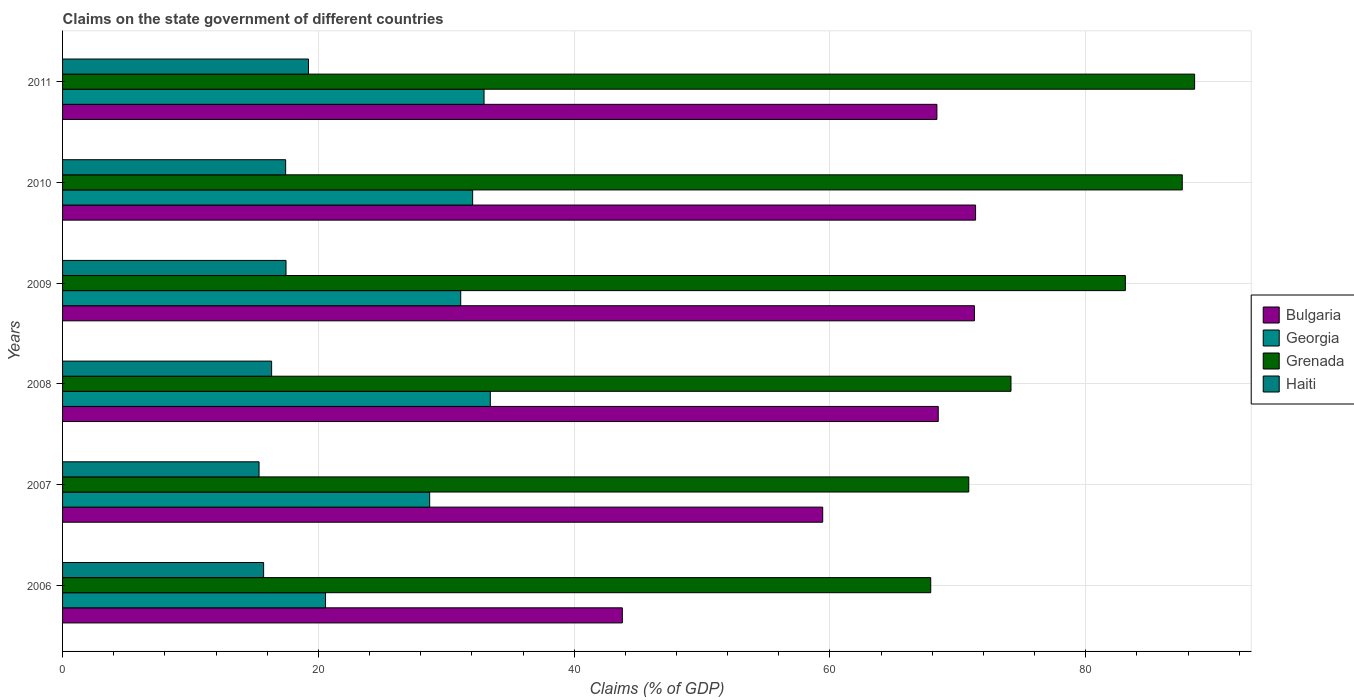How many groups of bars are there?
Your answer should be compact. 6. Are the number of bars per tick equal to the number of legend labels?
Your response must be concise. Yes. How many bars are there on the 4th tick from the top?
Give a very brief answer. 4. How many bars are there on the 6th tick from the bottom?
Ensure brevity in your answer.  4. What is the label of the 6th group of bars from the top?
Give a very brief answer. 2006. What is the percentage of GDP claimed on the state government in Grenada in 2008?
Provide a short and direct response. 74.15. Across all years, what is the maximum percentage of GDP claimed on the state government in Bulgaria?
Keep it short and to the point. 71.38. Across all years, what is the minimum percentage of GDP claimed on the state government in Bulgaria?
Your answer should be very brief. 43.77. In which year was the percentage of GDP claimed on the state government in Bulgaria maximum?
Make the answer very short. 2010. What is the total percentage of GDP claimed on the state government in Georgia in the graph?
Your answer should be compact. 178.85. What is the difference between the percentage of GDP claimed on the state government in Grenada in 2008 and that in 2010?
Offer a very short reply. -13.39. What is the difference between the percentage of GDP claimed on the state government in Haiti in 2010 and the percentage of GDP claimed on the state government in Bulgaria in 2011?
Offer a very short reply. -50.92. What is the average percentage of GDP claimed on the state government in Georgia per year?
Offer a very short reply. 29.81. In the year 2008, what is the difference between the percentage of GDP claimed on the state government in Georgia and percentage of GDP claimed on the state government in Haiti?
Your answer should be compact. 17.1. What is the ratio of the percentage of GDP claimed on the state government in Grenada in 2006 to that in 2010?
Offer a terse response. 0.78. Is the percentage of GDP claimed on the state government in Bulgaria in 2008 less than that in 2011?
Make the answer very short. No. What is the difference between the highest and the second highest percentage of GDP claimed on the state government in Bulgaria?
Keep it short and to the point. 0.09. What is the difference between the highest and the lowest percentage of GDP claimed on the state government in Grenada?
Keep it short and to the point. 20.63. What does the 2nd bar from the top in 2009 represents?
Your answer should be compact. Grenada. What does the 3rd bar from the bottom in 2011 represents?
Offer a very short reply. Grenada. How many bars are there?
Ensure brevity in your answer.  24. How many years are there in the graph?
Your response must be concise. 6. What is the difference between two consecutive major ticks on the X-axis?
Offer a terse response. 20. Does the graph contain any zero values?
Give a very brief answer. No. Does the graph contain grids?
Your answer should be very brief. Yes. Where does the legend appear in the graph?
Ensure brevity in your answer.  Center right. How many legend labels are there?
Your response must be concise. 4. What is the title of the graph?
Your response must be concise. Claims on the state government of different countries. What is the label or title of the X-axis?
Your answer should be compact. Claims (% of GDP). What is the label or title of the Y-axis?
Your answer should be compact. Years. What is the Claims (% of GDP) of Bulgaria in 2006?
Ensure brevity in your answer.  43.77. What is the Claims (% of GDP) in Georgia in 2006?
Keep it short and to the point. 20.56. What is the Claims (% of GDP) of Grenada in 2006?
Make the answer very short. 67.88. What is the Claims (% of GDP) in Haiti in 2006?
Offer a very short reply. 15.72. What is the Claims (% of GDP) in Bulgaria in 2007?
Give a very brief answer. 59.43. What is the Claims (% of GDP) of Georgia in 2007?
Make the answer very short. 28.7. What is the Claims (% of GDP) of Grenada in 2007?
Your answer should be compact. 70.85. What is the Claims (% of GDP) in Haiti in 2007?
Keep it short and to the point. 15.36. What is the Claims (% of GDP) in Bulgaria in 2008?
Your answer should be very brief. 68.46. What is the Claims (% of GDP) of Georgia in 2008?
Give a very brief answer. 33.44. What is the Claims (% of GDP) in Grenada in 2008?
Keep it short and to the point. 74.15. What is the Claims (% of GDP) in Haiti in 2008?
Your answer should be very brief. 16.34. What is the Claims (% of GDP) of Bulgaria in 2009?
Give a very brief answer. 71.29. What is the Claims (% of GDP) of Georgia in 2009?
Give a very brief answer. 31.13. What is the Claims (% of GDP) in Grenada in 2009?
Ensure brevity in your answer.  83.09. What is the Claims (% of GDP) in Haiti in 2009?
Give a very brief answer. 17.47. What is the Claims (% of GDP) of Bulgaria in 2010?
Offer a very short reply. 71.38. What is the Claims (% of GDP) of Georgia in 2010?
Offer a very short reply. 32.06. What is the Claims (% of GDP) of Grenada in 2010?
Make the answer very short. 87.54. What is the Claims (% of GDP) in Haiti in 2010?
Keep it short and to the point. 17.44. What is the Claims (% of GDP) of Bulgaria in 2011?
Your answer should be very brief. 68.36. What is the Claims (% of GDP) of Georgia in 2011?
Your response must be concise. 32.95. What is the Claims (% of GDP) in Grenada in 2011?
Your answer should be compact. 88.51. What is the Claims (% of GDP) in Haiti in 2011?
Make the answer very short. 19.23. Across all years, what is the maximum Claims (% of GDP) of Bulgaria?
Provide a succinct answer. 71.38. Across all years, what is the maximum Claims (% of GDP) in Georgia?
Make the answer very short. 33.44. Across all years, what is the maximum Claims (% of GDP) of Grenada?
Offer a very short reply. 88.51. Across all years, what is the maximum Claims (% of GDP) in Haiti?
Offer a terse response. 19.23. Across all years, what is the minimum Claims (% of GDP) of Bulgaria?
Your answer should be very brief. 43.77. Across all years, what is the minimum Claims (% of GDP) of Georgia?
Keep it short and to the point. 20.56. Across all years, what is the minimum Claims (% of GDP) of Grenada?
Your answer should be compact. 67.88. Across all years, what is the minimum Claims (% of GDP) in Haiti?
Offer a very short reply. 15.36. What is the total Claims (% of GDP) of Bulgaria in the graph?
Your answer should be very brief. 382.69. What is the total Claims (% of GDP) of Georgia in the graph?
Keep it short and to the point. 178.85. What is the total Claims (% of GDP) in Grenada in the graph?
Ensure brevity in your answer.  472.02. What is the total Claims (% of GDP) in Haiti in the graph?
Make the answer very short. 101.56. What is the difference between the Claims (% of GDP) in Bulgaria in 2006 and that in 2007?
Ensure brevity in your answer.  -15.66. What is the difference between the Claims (% of GDP) of Georgia in 2006 and that in 2007?
Your response must be concise. -8.14. What is the difference between the Claims (% of GDP) in Grenada in 2006 and that in 2007?
Ensure brevity in your answer.  -2.97. What is the difference between the Claims (% of GDP) of Haiti in 2006 and that in 2007?
Provide a short and direct response. 0.36. What is the difference between the Claims (% of GDP) of Bulgaria in 2006 and that in 2008?
Ensure brevity in your answer.  -24.7. What is the difference between the Claims (% of GDP) in Georgia in 2006 and that in 2008?
Your response must be concise. -12.88. What is the difference between the Claims (% of GDP) in Grenada in 2006 and that in 2008?
Ensure brevity in your answer.  -6.27. What is the difference between the Claims (% of GDP) in Haiti in 2006 and that in 2008?
Offer a very short reply. -0.62. What is the difference between the Claims (% of GDP) in Bulgaria in 2006 and that in 2009?
Provide a short and direct response. -27.53. What is the difference between the Claims (% of GDP) of Georgia in 2006 and that in 2009?
Provide a succinct answer. -10.57. What is the difference between the Claims (% of GDP) of Grenada in 2006 and that in 2009?
Give a very brief answer. -15.22. What is the difference between the Claims (% of GDP) of Haiti in 2006 and that in 2009?
Offer a very short reply. -1.75. What is the difference between the Claims (% of GDP) in Bulgaria in 2006 and that in 2010?
Your response must be concise. -27.62. What is the difference between the Claims (% of GDP) of Georgia in 2006 and that in 2010?
Your response must be concise. -11.5. What is the difference between the Claims (% of GDP) in Grenada in 2006 and that in 2010?
Make the answer very short. -19.66. What is the difference between the Claims (% of GDP) in Haiti in 2006 and that in 2010?
Provide a short and direct response. -1.72. What is the difference between the Claims (% of GDP) of Bulgaria in 2006 and that in 2011?
Make the answer very short. -24.59. What is the difference between the Claims (% of GDP) of Georgia in 2006 and that in 2011?
Make the answer very short. -12.39. What is the difference between the Claims (% of GDP) in Grenada in 2006 and that in 2011?
Provide a short and direct response. -20.63. What is the difference between the Claims (% of GDP) in Haiti in 2006 and that in 2011?
Make the answer very short. -3.51. What is the difference between the Claims (% of GDP) in Bulgaria in 2007 and that in 2008?
Provide a short and direct response. -9.03. What is the difference between the Claims (% of GDP) of Georgia in 2007 and that in 2008?
Your answer should be compact. -4.74. What is the difference between the Claims (% of GDP) in Grenada in 2007 and that in 2008?
Offer a very short reply. -3.3. What is the difference between the Claims (% of GDP) of Haiti in 2007 and that in 2008?
Give a very brief answer. -0.98. What is the difference between the Claims (% of GDP) of Bulgaria in 2007 and that in 2009?
Provide a succinct answer. -11.86. What is the difference between the Claims (% of GDP) of Georgia in 2007 and that in 2009?
Offer a terse response. -2.43. What is the difference between the Claims (% of GDP) of Grenada in 2007 and that in 2009?
Your answer should be very brief. -12.24. What is the difference between the Claims (% of GDP) of Haiti in 2007 and that in 2009?
Give a very brief answer. -2.11. What is the difference between the Claims (% of GDP) in Bulgaria in 2007 and that in 2010?
Your response must be concise. -11.95. What is the difference between the Claims (% of GDP) in Georgia in 2007 and that in 2010?
Your answer should be compact. -3.36. What is the difference between the Claims (% of GDP) in Grenada in 2007 and that in 2010?
Provide a succinct answer. -16.69. What is the difference between the Claims (% of GDP) in Haiti in 2007 and that in 2010?
Give a very brief answer. -2.08. What is the difference between the Claims (% of GDP) of Bulgaria in 2007 and that in 2011?
Your answer should be compact. -8.93. What is the difference between the Claims (% of GDP) in Georgia in 2007 and that in 2011?
Your answer should be compact. -4.25. What is the difference between the Claims (% of GDP) in Grenada in 2007 and that in 2011?
Keep it short and to the point. -17.66. What is the difference between the Claims (% of GDP) in Haiti in 2007 and that in 2011?
Give a very brief answer. -3.86. What is the difference between the Claims (% of GDP) in Bulgaria in 2008 and that in 2009?
Provide a succinct answer. -2.83. What is the difference between the Claims (% of GDP) in Georgia in 2008 and that in 2009?
Your answer should be very brief. 2.31. What is the difference between the Claims (% of GDP) in Grenada in 2008 and that in 2009?
Your answer should be compact. -8.94. What is the difference between the Claims (% of GDP) in Haiti in 2008 and that in 2009?
Your answer should be compact. -1.13. What is the difference between the Claims (% of GDP) in Bulgaria in 2008 and that in 2010?
Keep it short and to the point. -2.92. What is the difference between the Claims (% of GDP) in Georgia in 2008 and that in 2010?
Ensure brevity in your answer.  1.38. What is the difference between the Claims (% of GDP) in Grenada in 2008 and that in 2010?
Give a very brief answer. -13.39. What is the difference between the Claims (% of GDP) in Haiti in 2008 and that in 2010?
Make the answer very short. -1.1. What is the difference between the Claims (% of GDP) in Bulgaria in 2008 and that in 2011?
Your answer should be compact. 0.1. What is the difference between the Claims (% of GDP) of Georgia in 2008 and that in 2011?
Provide a succinct answer. 0.49. What is the difference between the Claims (% of GDP) in Grenada in 2008 and that in 2011?
Ensure brevity in your answer.  -14.36. What is the difference between the Claims (% of GDP) in Haiti in 2008 and that in 2011?
Keep it short and to the point. -2.88. What is the difference between the Claims (% of GDP) of Bulgaria in 2009 and that in 2010?
Your response must be concise. -0.09. What is the difference between the Claims (% of GDP) of Georgia in 2009 and that in 2010?
Give a very brief answer. -0.93. What is the difference between the Claims (% of GDP) of Grenada in 2009 and that in 2010?
Offer a terse response. -4.45. What is the difference between the Claims (% of GDP) of Haiti in 2009 and that in 2010?
Keep it short and to the point. 0.03. What is the difference between the Claims (% of GDP) of Bulgaria in 2009 and that in 2011?
Give a very brief answer. 2.93. What is the difference between the Claims (% of GDP) of Georgia in 2009 and that in 2011?
Make the answer very short. -1.82. What is the difference between the Claims (% of GDP) of Grenada in 2009 and that in 2011?
Offer a very short reply. -5.41. What is the difference between the Claims (% of GDP) of Haiti in 2009 and that in 2011?
Provide a succinct answer. -1.76. What is the difference between the Claims (% of GDP) in Bulgaria in 2010 and that in 2011?
Make the answer very short. 3.02. What is the difference between the Claims (% of GDP) of Georgia in 2010 and that in 2011?
Offer a very short reply. -0.89. What is the difference between the Claims (% of GDP) of Grenada in 2010 and that in 2011?
Your answer should be compact. -0.97. What is the difference between the Claims (% of GDP) of Haiti in 2010 and that in 2011?
Your response must be concise. -1.78. What is the difference between the Claims (% of GDP) in Bulgaria in 2006 and the Claims (% of GDP) in Georgia in 2007?
Your answer should be compact. 15.06. What is the difference between the Claims (% of GDP) in Bulgaria in 2006 and the Claims (% of GDP) in Grenada in 2007?
Give a very brief answer. -27.09. What is the difference between the Claims (% of GDP) in Bulgaria in 2006 and the Claims (% of GDP) in Haiti in 2007?
Make the answer very short. 28.4. What is the difference between the Claims (% of GDP) in Georgia in 2006 and the Claims (% of GDP) in Grenada in 2007?
Offer a terse response. -50.29. What is the difference between the Claims (% of GDP) of Georgia in 2006 and the Claims (% of GDP) of Haiti in 2007?
Make the answer very short. 5.2. What is the difference between the Claims (% of GDP) of Grenada in 2006 and the Claims (% of GDP) of Haiti in 2007?
Offer a terse response. 52.51. What is the difference between the Claims (% of GDP) of Bulgaria in 2006 and the Claims (% of GDP) of Georgia in 2008?
Provide a succinct answer. 10.32. What is the difference between the Claims (% of GDP) in Bulgaria in 2006 and the Claims (% of GDP) in Grenada in 2008?
Your answer should be very brief. -30.39. What is the difference between the Claims (% of GDP) in Bulgaria in 2006 and the Claims (% of GDP) in Haiti in 2008?
Provide a succinct answer. 27.42. What is the difference between the Claims (% of GDP) in Georgia in 2006 and the Claims (% of GDP) in Grenada in 2008?
Your response must be concise. -53.59. What is the difference between the Claims (% of GDP) of Georgia in 2006 and the Claims (% of GDP) of Haiti in 2008?
Provide a short and direct response. 4.22. What is the difference between the Claims (% of GDP) of Grenada in 2006 and the Claims (% of GDP) of Haiti in 2008?
Offer a very short reply. 51.53. What is the difference between the Claims (% of GDP) of Bulgaria in 2006 and the Claims (% of GDP) of Georgia in 2009?
Make the answer very short. 12.64. What is the difference between the Claims (% of GDP) of Bulgaria in 2006 and the Claims (% of GDP) of Grenada in 2009?
Provide a succinct answer. -39.33. What is the difference between the Claims (% of GDP) in Bulgaria in 2006 and the Claims (% of GDP) in Haiti in 2009?
Offer a very short reply. 26.3. What is the difference between the Claims (% of GDP) of Georgia in 2006 and the Claims (% of GDP) of Grenada in 2009?
Your answer should be very brief. -62.53. What is the difference between the Claims (% of GDP) in Georgia in 2006 and the Claims (% of GDP) in Haiti in 2009?
Provide a short and direct response. 3.09. What is the difference between the Claims (% of GDP) of Grenada in 2006 and the Claims (% of GDP) of Haiti in 2009?
Offer a terse response. 50.41. What is the difference between the Claims (% of GDP) in Bulgaria in 2006 and the Claims (% of GDP) in Georgia in 2010?
Keep it short and to the point. 11.7. What is the difference between the Claims (% of GDP) of Bulgaria in 2006 and the Claims (% of GDP) of Grenada in 2010?
Provide a short and direct response. -43.78. What is the difference between the Claims (% of GDP) of Bulgaria in 2006 and the Claims (% of GDP) of Haiti in 2010?
Offer a terse response. 26.32. What is the difference between the Claims (% of GDP) in Georgia in 2006 and the Claims (% of GDP) in Grenada in 2010?
Give a very brief answer. -66.98. What is the difference between the Claims (% of GDP) of Georgia in 2006 and the Claims (% of GDP) of Haiti in 2010?
Give a very brief answer. 3.12. What is the difference between the Claims (% of GDP) in Grenada in 2006 and the Claims (% of GDP) in Haiti in 2010?
Provide a succinct answer. 50.44. What is the difference between the Claims (% of GDP) of Bulgaria in 2006 and the Claims (% of GDP) of Georgia in 2011?
Offer a terse response. 10.81. What is the difference between the Claims (% of GDP) of Bulgaria in 2006 and the Claims (% of GDP) of Grenada in 2011?
Keep it short and to the point. -44.74. What is the difference between the Claims (% of GDP) of Bulgaria in 2006 and the Claims (% of GDP) of Haiti in 2011?
Provide a succinct answer. 24.54. What is the difference between the Claims (% of GDP) of Georgia in 2006 and the Claims (% of GDP) of Grenada in 2011?
Make the answer very short. -67.95. What is the difference between the Claims (% of GDP) of Georgia in 2006 and the Claims (% of GDP) of Haiti in 2011?
Your answer should be compact. 1.33. What is the difference between the Claims (% of GDP) in Grenada in 2006 and the Claims (% of GDP) in Haiti in 2011?
Provide a short and direct response. 48.65. What is the difference between the Claims (% of GDP) of Bulgaria in 2007 and the Claims (% of GDP) of Georgia in 2008?
Your response must be concise. 25.99. What is the difference between the Claims (% of GDP) of Bulgaria in 2007 and the Claims (% of GDP) of Grenada in 2008?
Your answer should be very brief. -14.72. What is the difference between the Claims (% of GDP) of Bulgaria in 2007 and the Claims (% of GDP) of Haiti in 2008?
Offer a very short reply. 43.09. What is the difference between the Claims (% of GDP) in Georgia in 2007 and the Claims (% of GDP) in Grenada in 2008?
Your response must be concise. -45.45. What is the difference between the Claims (% of GDP) in Georgia in 2007 and the Claims (% of GDP) in Haiti in 2008?
Provide a succinct answer. 12.36. What is the difference between the Claims (% of GDP) of Grenada in 2007 and the Claims (% of GDP) of Haiti in 2008?
Your answer should be compact. 54.51. What is the difference between the Claims (% of GDP) in Bulgaria in 2007 and the Claims (% of GDP) in Georgia in 2009?
Your response must be concise. 28.3. What is the difference between the Claims (% of GDP) of Bulgaria in 2007 and the Claims (% of GDP) of Grenada in 2009?
Provide a succinct answer. -23.66. What is the difference between the Claims (% of GDP) in Bulgaria in 2007 and the Claims (% of GDP) in Haiti in 2009?
Make the answer very short. 41.96. What is the difference between the Claims (% of GDP) of Georgia in 2007 and the Claims (% of GDP) of Grenada in 2009?
Ensure brevity in your answer.  -54.39. What is the difference between the Claims (% of GDP) of Georgia in 2007 and the Claims (% of GDP) of Haiti in 2009?
Offer a terse response. 11.23. What is the difference between the Claims (% of GDP) in Grenada in 2007 and the Claims (% of GDP) in Haiti in 2009?
Provide a short and direct response. 53.38. What is the difference between the Claims (% of GDP) in Bulgaria in 2007 and the Claims (% of GDP) in Georgia in 2010?
Your answer should be very brief. 27.37. What is the difference between the Claims (% of GDP) of Bulgaria in 2007 and the Claims (% of GDP) of Grenada in 2010?
Make the answer very short. -28.11. What is the difference between the Claims (% of GDP) in Bulgaria in 2007 and the Claims (% of GDP) in Haiti in 2010?
Provide a succinct answer. 41.99. What is the difference between the Claims (% of GDP) in Georgia in 2007 and the Claims (% of GDP) in Grenada in 2010?
Keep it short and to the point. -58.84. What is the difference between the Claims (% of GDP) of Georgia in 2007 and the Claims (% of GDP) of Haiti in 2010?
Your answer should be very brief. 11.26. What is the difference between the Claims (% of GDP) in Grenada in 2007 and the Claims (% of GDP) in Haiti in 2010?
Offer a terse response. 53.41. What is the difference between the Claims (% of GDP) in Bulgaria in 2007 and the Claims (% of GDP) in Georgia in 2011?
Your answer should be compact. 26.48. What is the difference between the Claims (% of GDP) of Bulgaria in 2007 and the Claims (% of GDP) of Grenada in 2011?
Ensure brevity in your answer.  -29.08. What is the difference between the Claims (% of GDP) in Bulgaria in 2007 and the Claims (% of GDP) in Haiti in 2011?
Make the answer very short. 40.2. What is the difference between the Claims (% of GDP) of Georgia in 2007 and the Claims (% of GDP) of Grenada in 2011?
Offer a terse response. -59.8. What is the difference between the Claims (% of GDP) in Georgia in 2007 and the Claims (% of GDP) in Haiti in 2011?
Make the answer very short. 9.48. What is the difference between the Claims (% of GDP) of Grenada in 2007 and the Claims (% of GDP) of Haiti in 2011?
Your response must be concise. 51.62. What is the difference between the Claims (% of GDP) of Bulgaria in 2008 and the Claims (% of GDP) of Georgia in 2009?
Keep it short and to the point. 37.33. What is the difference between the Claims (% of GDP) of Bulgaria in 2008 and the Claims (% of GDP) of Grenada in 2009?
Your response must be concise. -14.63. What is the difference between the Claims (% of GDP) in Bulgaria in 2008 and the Claims (% of GDP) in Haiti in 2009?
Your answer should be very brief. 50.99. What is the difference between the Claims (% of GDP) of Georgia in 2008 and the Claims (% of GDP) of Grenada in 2009?
Give a very brief answer. -49.65. What is the difference between the Claims (% of GDP) of Georgia in 2008 and the Claims (% of GDP) of Haiti in 2009?
Give a very brief answer. 15.97. What is the difference between the Claims (% of GDP) in Grenada in 2008 and the Claims (% of GDP) in Haiti in 2009?
Your answer should be compact. 56.68. What is the difference between the Claims (% of GDP) in Bulgaria in 2008 and the Claims (% of GDP) in Georgia in 2010?
Your answer should be very brief. 36.4. What is the difference between the Claims (% of GDP) of Bulgaria in 2008 and the Claims (% of GDP) of Grenada in 2010?
Offer a very short reply. -19.08. What is the difference between the Claims (% of GDP) in Bulgaria in 2008 and the Claims (% of GDP) in Haiti in 2010?
Provide a short and direct response. 51.02. What is the difference between the Claims (% of GDP) of Georgia in 2008 and the Claims (% of GDP) of Grenada in 2010?
Your answer should be compact. -54.1. What is the difference between the Claims (% of GDP) in Georgia in 2008 and the Claims (% of GDP) in Haiti in 2010?
Make the answer very short. 16. What is the difference between the Claims (% of GDP) of Grenada in 2008 and the Claims (% of GDP) of Haiti in 2010?
Make the answer very short. 56.71. What is the difference between the Claims (% of GDP) of Bulgaria in 2008 and the Claims (% of GDP) of Georgia in 2011?
Your answer should be very brief. 35.51. What is the difference between the Claims (% of GDP) of Bulgaria in 2008 and the Claims (% of GDP) of Grenada in 2011?
Offer a very short reply. -20.04. What is the difference between the Claims (% of GDP) of Bulgaria in 2008 and the Claims (% of GDP) of Haiti in 2011?
Ensure brevity in your answer.  49.24. What is the difference between the Claims (% of GDP) of Georgia in 2008 and the Claims (% of GDP) of Grenada in 2011?
Provide a short and direct response. -55.06. What is the difference between the Claims (% of GDP) of Georgia in 2008 and the Claims (% of GDP) of Haiti in 2011?
Ensure brevity in your answer.  14.22. What is the difference between the Claims (% of GDP) in Grenada in 2008 and the Claims (% of GDP) in Haiti in 2011?
Your answer should be very brief. 54.93. What is the difference between the Claims (% of GDP) in Bulgaria in 2009 and the Claims (% of GDP) in Georgia in 2010?
Keep it short and to the point. 39.23. What is the difference between the Claims (% of GDP) of Bulgaria in 2009 and the Claims (% of GDP) of Grenada in 2010?
Make the answer very short. -16.25. What is the difference between the Claims (% of GDP) in Bulgaria in 2009 and the Claims (% of GDP) in Haiti in 2010?
Provide a short and direct response. 53.85. What is the difference between the Claims (% of GDP) in Georgia in 2009 and the Claims (% of GDP) in Grenada in 2010?
Ensure brevity in your answer.  -56.41. What is the difference between the Claims (% of GDP) in Georgia in 2009 and the Claims (% of GDP) in Haiti in 2010?
Ensure brevity in your answer.  13.69. What is the difference between the Claims (% of GDP) in Grenada in 2009 and the Claims (% of GDP) in Haiti in 2010?
Provide a succinct answer. 65.65. What is the difference between the Claims (% of GDP) of Bulgaria in 2009 and the Claims (% of GDP) of Georgia in 2011?
Make the answer very short. 38.34. What is the difference between the Claims (% of GDP) in Bulgaria in 2009 and the Claims (% of GDP) in Grenada in 2011?
Ensure brevity in your answer.  -17.22. What is the difference between the Claims (% of GDP) in Bulgaria in 2009 and the Claims (% of GDP) in Haiti in 2011?
Give a very brief answer. 52.07. What is the difference between the Claims (% of GDP) of Georgia in 2009 and the Claims (% of GDP) of Grenada in 2011?
Your answer should be very brief. -57.38. What is the difference between the Claims (% of GDP) in Georgia in 2009 and the Claims (% of GDP) in Haiti in 2011?
Keep it short and to the point. 11.9. What is the difference between the Claims (% of GDP) of Grenada in 2009 and the Claims (% of GDP) of Haiti in 2011?
Your answer should be very brief. 63.87. What is the difference between the Claims (% of GDP) of Bulgaria in 2010 and the Claims (% of GDP) of Georgia in 2011?
Your response must be concise. 38.43. What is the difference between the Claims (% of GDP) of Bulgaria in 2010 and the Claims (% of GDP) of Grenada in 2011?
Ensure brevity in your answer.  -17.12. What is the difference between the Claims (% of GDP) in Bulgaria in 2010 and the Claims (% of GDP) in Haiti in 2011?
Ensure brevity in your answer.  52.16. What is the difference between the Claims (% of GDP) in Georgia in 2010 and the Claims (% of GDP) in Grenada in 2011?
Provide a succinct answer. -56.44. What is the difference between the Claims (% of GDP) of Georgia in 2010 and the Claims (% of GDP) of Haiti in 2011?
Provide a succinct answer. 12.84. What is the difference between the Claims (% of GDP) of Grenada in 2010 and the Claims (% of GDP) of Haiti in 2011?
Give a very brief answer. 68.32. What is the average Claims (% of GDP) in Bulgaria per year?
Provide a short and direct response. 63.78. What is the average Claims (% of GDP) in Georgia per year?
Make the answer very short. 29.81. What is the average Claims (% of GDP) in Grenada per year?
Your response must be concise. 78.67. What is the average Claims (% of GDP) of Haiti per year?
Your response must be concise. 16.93. In the year 2006, what is the difference between the Claims (% of GDP) in Bulgaria and Claims (% of GDP) in Georgia?
Ensure brevity in your answer.  23.21. In the year 2006, what is the difference between the Claims (% of GDP) of Bulgaria and Claims (% of GDP) of Grenada?
Provide a succinct answer. -24.11. In the year 2006, what is the difference between the Claims (% of GDP) in Bulgaria and Claims (% of GDP) in Haiti?
Ensure brevity in your answer.  28.05. In the year 2006, what is the difference between the Claims (% of GDP) in Georgia and Claims (% of GDP) in Grenada?
Provide a short and direct response. -47.32. In the year 2006, what is the difference between the Claims (% of GDP) of Georgia and Claims (% of GDP) of Haiti?
Make the answer very short. 4.84. In the year 2006, what is the difference between the Claims (% of GDP) in Grenada and Claims (% of GDP) in Haiti?
Provide a succinct answer. 52.16. In the year 2007, what is the difference between the Claims (% of GDP) in Bulgaria and Claims (% of GDP) in Georgia?
Your answer should be compact. 30.73. In the year 2007, what is the difference between the Claims (% of GDP) of Bulgaria and Claims (% of GDP) of Grenada?
Make the answer very short. -11.42. In the year 2007, what is the difference between the Claims (% of GDP) of Bulgaria and Claims (% of GDP) of Haiti?
Your answer should be very brief. 44.07. In the year 2007, what is the difference between the Claims (% of GDP) of Georgia and Claims (% of GDP) of Grenada?
Ensure brevity in your answer.  -42.15. In the year 2007, what is the difference between the Claims (% of GDP) in Georgia and Claims (% of GDP) in Haiti?
Provide a short and direct response. 13.34. In the year 2007, what is the difference between the Claims (% of GDP) of Grenada and Claims (% of GDP) of Haiti?
Your response must be concise. 55.49. In the year 2008, what is the difference between the Claims (% of GDP) of Bulgaria and Claims (% of GDP) of Georgia?
Your response must be concise. 35.02. In the year 2008, what is the difference between the Claims (% of GDP) of Bulgaria and Claims (% of GDP) of Grenada?
Provide a short and direct response. -5.69. In the year 2008, what is the difference between the Claims (% of GDP) of Bulgaria and Claims (% of GDP) of Haiti?
Your response must be concise. 52.12. In the year 2008, what is the difference between the Claims (% of GDP) of Georgia and Claims (% of GDP) of Grenada?
Offer a very short reply. -40.71. In the year 2008, what is the difference between the Claims (% of GDP) of Georgia and Claims (% of GDP) of Haiti?
Offer a terse response. 17.1. In the year 2008, what is the difference between the Claims (% of GDP) in Grenada and Claims (% of GDP) in Haiti?
Offer a very short reply. 57.81. In the year 2009, what is the difference between the Claims (% of GDP) in Bulgaria and Claims (% of GDP) in Georgia?
Offer a very short reply. 40.16. In the year 2009, what is the difference between the Claims (% of GDP) in Bulgaria and Claims (% of GDP) in Grenada?
Give a very brief answer. -11.8. In the year 2009, what is the difference between the Claims (% of GDP) of Bulgaria and Claims (% of GDP) of Haiti?
Your response must be concise. 53.82. In the year 2009, what is the difference between the Claims (% of GDP) of Georgia and Claims (% of GDP) of Grenada?
Ensure brevity in your answer.  -51.96. In the year 2009, what is the difference between the Claims (% of GDP) in Georgia and Claims (% of GDP) in Haiti?
Your answer should be very brief. 13.66. In the year 2009, what is the difference between the Claims (% of GDP) in Grenada and Claims (% of GDP) in Haiti?
Ensure brevity in your answer.  65.62. In the year 2010, what is the difference between the Claims (% of GDP) in Bulgaria and Claims (% of GDP) in Georgia?
Give a very brief answer. 39.32. In the year 2010, what is the difference between the Claims (% of GDP) in Bulgaria and Claims (% of GDP) in Grenada?
Provide a succinct answer. -16.16. In the year 2010, what is the difference between the Claims (% of GDP) in Bulgaria and Claims (% of GDP) in Haiti?
Offer a terse response. 53.94. In the year 2010, what is the difference between the Claims (% of GDP) of Georgia and Claims (% of GDP) of Grenada?
Give a very brief answer. -55.48. In the year 2010, what is the difference between the Claims (% of GDP) in Georgia and Claims (% of GDP) in Haiti?
Keep it short and to the point. 14.62. In the year 2010, what is the difference between the Claims (% of GDP) in Grenada and Claims (% of GDP) in Haiti?
Your answer should be very brief. 70.1. In the year 2011, what is the difference between the Claims (% of GDP) in Bulgaria and Claims (% of GDP) in Georgia?
Ensure brevity in your answer.  35.41. In the year 2011, what is the difference between the Claims (% of GDP) in Bulgaria and Claims (% of GDP) in Grenada?
Ensure brevity in your answer.  -20.15. In the year 2011, what is the difference between the Claims (% of GDP) in Bulgaria and Claims (% of GDP) in Haiti?
Ensure brevity in your answer.  49.13. In the year 2011, what is the difference between the Claims (% of GDP) of Georgia and Claims (% of GDP) of Grenada?
Your response must be concise. -55.55. In the year 2011, what is the difference between the Claims (% of GDP) in Georgia and Claims (% of GDP) in Haiti?
Give a very brief answer. 13.73. In the year 2011, what is the difference between the Claims (% of GDP) of Grenada and Claims (% of GDP) of Haiti?
Give a very brief answer. 69.28. What is the ratio of the Claims (% of GDP) of Bulgaria in 2006 to that in 2007?
Give a very brief answer. 0.74. What is the ratio of the Claims (% of GDP) of Georgia in 2006 to that in 2007?
Offer a very short reply. 0.72. What is the ratio of the Claims (% of GDP) in Grenada in 2006 to that in 2007?
Offer a terse response. 0.96. What is the ratio of the Claims (% of GDP) in Haiti in 2006 to that in 2007?
Offer a very short reply. 1.02. What is the ratio of the Claims (% of GDP) of Bulgaria in 2006 to that in 2008?
Ensure brevity in your answer.  0.64. What is the ratio of the Claims (% of GDP) of Georgia in 2006 to that in 2008?
Keep it short and to the point. 0.61. What is the ratio of the Claims (% of GDP) in Grenada in 2006 to that in 2008?
Offer a very short reply. 0.92. What is the ratio of the Claims (% of GDP) of Haiti in 2006 to that in 2008?
Your answer should be compact. 0.96. What is the ratio of the Claims (% of GDP) of Bulgaria in 2006 to that in 2009?
Ensure brevity in your answer.  0.61. What is the ratio of the Claims (% of GDP) in Georgia in 2006 to that in 2009?
Give a very brief answer. 0.66. What is the ratio of the Claims (% of GDP) in Grenada in 2006 to that in 2009?
Offer a terse response. 0.82. What is the ratio of the Claims (% of GDP) in Haiti in 2006 to that in 2009?
Keep it short and to the point. 0.9. What is the ratio of the Claims (% of GDP) in Bulgaria in 2006 to that in 2010?
Offer a very short reply. 0.61. What is the ratio of the Claims (% of GDP) in Georgia in 2006 to that in 2010?
Your answer should be compact. 0.64. What is the ratio of the Claims (% of GDP) in Grenada in 2006 to that in 2010?
Your answer should be compact. 0.78. What is the ratio of the Claims (% of GDP) of Haiti in 2006 to that in 2010?
Offer a terse response. 0.9. What is the ratio of the Claims (% of GDP) in Bulgaria in 2006 to that in 2011?
Provide a succinct answer. 0.64. What is the ratio of the Claims (% of GDP) of Georgia in 2006 to that in 2011?
Provide a succinct answer. 0.62. What is the ratio of the Claims (% of GDP) in Grenada in 2006 to that in 2011?
Your answer should be compact. 0.77. What is the ratio of the Claims (% of GDP) of Haiti in 2006 to that in 2011?
Your answer should be compact. 0.82. What is the ratio of the Claims (% of GDP) of Bulgaria in 2007 to that in 2008?
Keep it short and to the point. 0.87. What is the ratio of the Claims (% of GDP) of Georgia in 2007 to that in 2008?
Provide a succinct answer. 0.86. What is the ratio of the Claims (% of GDP) in Grenada in 2007 to that in 2008?
Your answer should be compact. 0.96. What is the ratio of the Claims (% of GDP) of Haiti in 2007 to that in 2008?
Ensure brevity in your answer.  0.94. What is the ratio of the Claims (% of GDP) of Bulgaria in 2007 to that in 2009?
Your response must be concise. 0.83. What is the ratio of the Claims (% of GDP) of Georgia in 2007 to that in 2009?
Offer a very short reply. 0.92. What is the ratio of the Claims (% of GDP) in Grenada in 2007 to that in 2009?
Make the answer very short. 0.85. What is the ratio of the Claims (% of GDP) of Haiti in 2007 to that in 2009?
Your answer should be very brief. 0.88. What is the ratio of the Claims (% of GDP) of Bulgaria in 2007 to that in 2010?
Make the answer very short. 0.83. What is the ratio of the Claims (% of GDP) in Georgia in 2007 to that in 2010?
Your answer should be very brief. 0.9. What is the ratio of the Claims (% of GDP) in Grenada in 2007 to that in 2010?
Make the answer very short. 0.81. What is the ratio of the Claims (% of GDP) in Haiti in 2007 to that in 2010?
Your answer should be compact. 0.88. What is the ratio of the Claims (% of GDP) in Bulgaria in 2007 to that in 2011?
Ensure brevity in your answer.  0.87. What is the ratio of the Claims (% of GDP) of Georgia in 2007 to that in 2011?
Give a very brief answer. 0.87. What is the ratio of the Claims (% of GDP) of Grenada in 2007 to that in 2011?
Provide a short and direct response. 0.8. What is the ratio of the Claims (% of GDP) in Haiti in 2007 to that in 2011?
Your answer should be very brief. 0.8. What is the ratio of the Claims (% of GDP) in Bulgaria in 2008 to that in 2009?
Provide a succinct answer. 0.96. What is the ratio of the Claims (% of GDP) of Georgia in 2008 to that in 2009?
Your answer should be compact. 1.07. What is the ratio of the Claims (% of GDP) of Grenada in 2008 to that in 2009?
Give a very brief answer. 0.89. What is the ratio of the Claims (% of GDP) in Haiti in 2008 to that in 2009?
Ensure brevity in your answer.  0.94. What is the ratio of the Claims (% of GDP) of Bulgaria in 2008 to that in 2010?
Offer a terse response. 0.96. What is the ratio of the Claims (% of GDP) in Georgia in 2008 to that in 2010?
Keep it short and to the point. 1.04. What is the ratio of the Claims (% of GDP) of Grenada in 2008 to that in 2010?
Offer a terse response. 0.85. What is the ratio of the Claims (% of GDP) in Haiti in 2008 to that in 2010?
Your answer should be very brief. 0.94. What is the ratio of the Claims (% of GDP) of Georgia in 2008 to that in 2011?
Provide a succinct answer. 1.01. What is the ratio of the Claims (% of GDP) in Grenada in 2008 to that in 2011?
Provide a short and direct response. 0.84. What is the ratio of the Claims (% of GDP) in Haiti in 2008 to that in 2011?
Provide a succinct answer. 0.85. What is the ratio of the Claims (% of GDP) of Bulgaria in 2009 to that in 2010?
Ensure brevity in your answer.  1. What is the ratio of the Claims (% of GDP) of Georgia in 2009 to that in 2010?
Keep it short and to the point. 0.97. What is the ratio of the Claims (% of GDP) of Grenada in 2009 to that in 2010?
Provide a succinct answer. 0.95. What is the ratio of the Claims (% of GDP) of Haiti in 2009 to that in 2010?
Offer a terse response. 1. What is the ratio of the Claims (% of GDP) of Bulgaria in 2009 to that in 2011?
Your answer should be compact. 1.04. What is the ratio of the Claims (% of GDP) of Georgia in 2009 to that in 2011?
Provide a short and direct response. 0.94. What is the ratio of the Claims (% of GDP) in Grenada in 2009 to that in 2011?
Make the answer very short. 0.94. What is the ratio of the Claims (% of GDP) of Haiti in 2009 to that in 2011?
Offer a very short reply. 0.91. What is the ratio of the Claims (% of GDP) of Bulgaria in 2010 to that in 2011?
Your response must be concise. 1.04. What is the ratio of the Claims (% of GDP) of Georgia in 2010 to that in 2011?
Offer a very short reply. 0.97. What is the ratio of the Claims (% of GDP) in Haiti in 2010 to that in 2011?
Offer a very short reply. 0.91. What is the difference between the highest and the second highest Claims (% of GDP) of Bulgaria?
Your answer should be compact. 0.09. What is the difference between the highest and the second highest Claims (% of GDP) of Georgia?
Offer a terse response. 0.49. What is the difference between the highest and the second highest Claims (% of GDP) of Grenada?
Provide a succinct answer. 0.97. What is the difference between the highest and the second highest Claims (% of GDP) in Haiti?
Provide a succinct answer. 1.76. What is the difference between the highest and the lowest Claims (% of GDP) of Bulgaria?
Provide a succinct answer. 27.62. What is the difference between the highest and the lowest Claims (% of GDP) of Georgia?
Offer a terse response. 12.88. What is the difference between the highest and the lowest Claims (% of GDP) in Grenada?
Give a very brief answer. 20.63. What is the difference between the highest and the lowest Claims (% of GDP) of Haiti?
Provide a short and direct response. 3.86. 